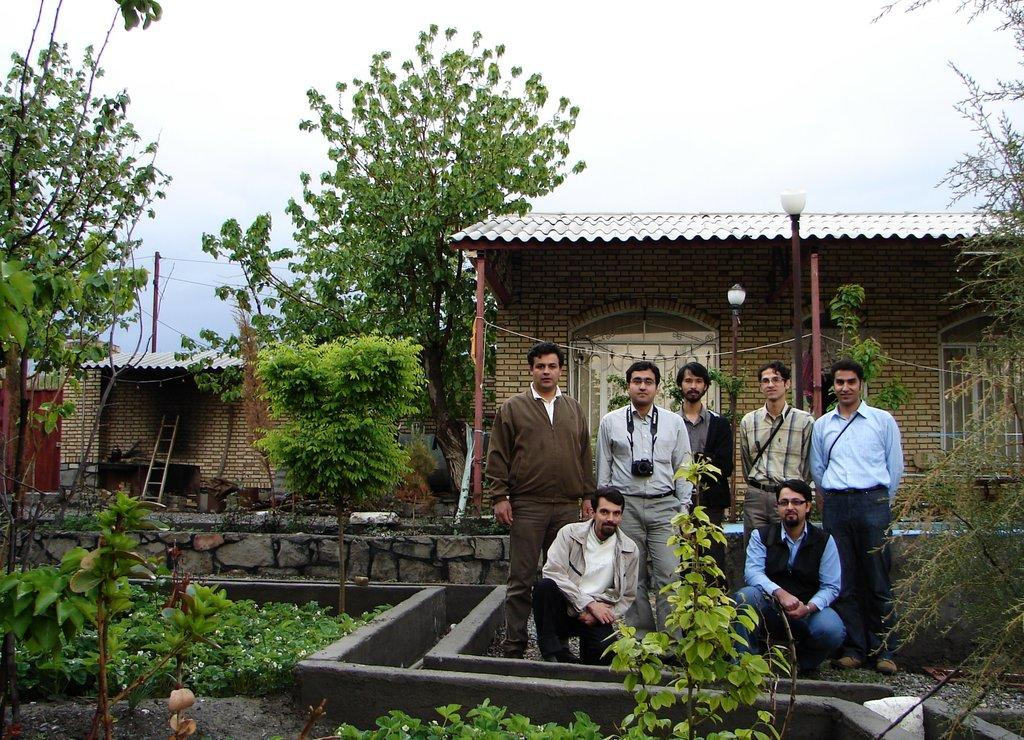What type of structure is visible in the image? There is a house in the image. Where is the shed located in the image? The shed is on the left side of the image. What type of vegetation can be seen in the image? There are trees and plants in the image. What are the people in the image doing? There are people standing in the image. What type of lighting is present in the image? There are pole lights in the image. How would you describe the weather in the image? The sky is cloudy in the image. What type of sack is being used by the people in the image? There is no sack present in the image; the people are simply standing. What is the main character's desire in the image? The image does not depict a fictional story or character, so there is no desire to be addressed. 